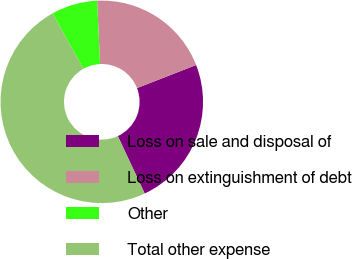Convert chart to OTSL. <chart><loc_0><loc_0><loc_500><loc_500><pie_chart><fcel>Loss on sale and disposal of<fcel>Loss on extinguishment of debt<fcel>Other<fcel>Total other expense<nl><fcel>23.96%<fcel>19.81%<fcel>7.35%<fcel>48.88%<nl></chart> 